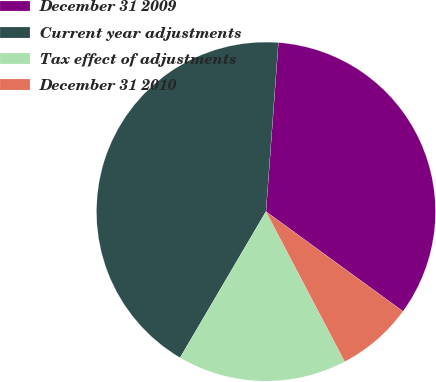Convert chart to OTSL. <chart><loc_0><loc_0><loc_500><loc_500><pie_chart><fcel>December 31 2009<fcel>Current year adjustments<fcel>Tax effect of adjustments<fcel>December 31 2010<nl><fcel>33.85%<fcel>42.71%<fcel>16.15%<fcel>7.29%<nl></chart> 